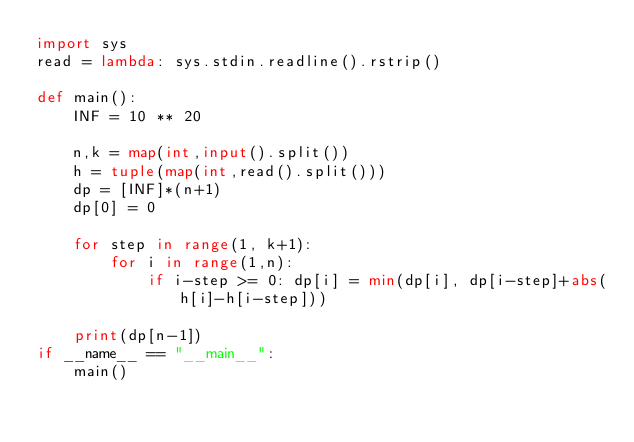<code> <loc_0><loc_0><loc_500><loc_500><_Python_>import sys
read = lambda: sys.stdin.readline().rstrip()
 
def main():
    INF = 10 ** 20
 
    n,k = map(int,input().split())
    h = tuple(map(int,read().split()))
    dp = [INF]*(n+1)
    dp[0] = 0
 
    for step in range(1, k+1):
        for i in range(1,n):
            if i-step >= 0: dp[i] = min(dp[i], dp[i-step]+abs(h[i]-h[i-step]))
 
    print(dp[n-1])
if __name__ == "__main__":
    main()</code> 